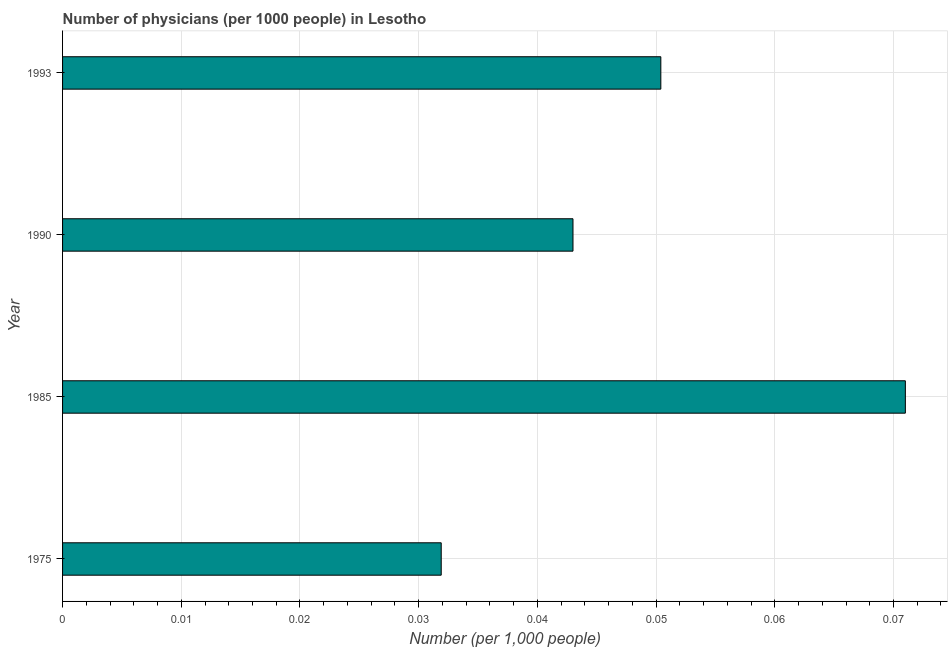Does the graph contain grids?
Your answer should be compact. Yes. What is the title of the graph?
Ensure brevity in your answer.  Number of physicians (per 1000 people) in Lesotho. What is the label or title of the X-axis?
Offer a very short reply. Number (per 1,0 people). What is the label or title of the Y-axis?
Provide a short and direct response. Year. What is the number of physicians in 1985?
Give a very brief answer. 0.07. Across all years, what is the maximum number of physicians?
Your answer should be very brief. 0.07. Across all years, what is the minimum number of physicians?
Offer a terse response. 0.03. In which year was the number of physicians minimum?
Provide a short and direct response. 1975. What is the sum of the number of physicians?
Offer a terse response. 0.2. What is the difference between the number of physicians in 1975 and 1990?
Provide a short and direct response. -0.01. What is the average number of physicians per year?
Your answer should be compact. 0.05. What is the median number of physicians?
Offer a very short reply. 0.05. Do a majority of the years between 1990 and 1985 (inclusive) have number of physicians greater than 0.04 ?
Give a very brief answer. No. What is the ratio of the number of physicians in 1975 to that in 1985?
Your response must be concise. 0.45. Is the number of physicians in 1985 less than that in 1990?
Your answer should be compact. No. Is the difference between the number of physicians in 1975 and 1993 greater than the difference between any two years?
Provide a short and direct response. No. What is the difference between the highest and the second highest number of physicians?
Your answer should be very brief. 0.02. What is the difference between the highest and the lowest number of physicians?
Give a very brief answer. 0.04. What is the difference between two consecutive major ticks on the X-axis?
Make the answer very short. 0.01. What is the Number (per 1,000 people) of 1975?
Your response must be concise. 0.03. What is the Number (per 1,000 people) in 1985?
Provide a short and direct response. 0.07. What is the Number (per 1,000 people) of 1990?
Provide a succinct answer. 0.04. What is the Number (per 1,000 people) of 1993?
Make the answer very short. 0.05. What is the difference between the Number (per 1,000 people) in 1975 and 1985?
Keep it short and to the point. -0.04. What is the difference between the Number (per 1,000 people) in 1975 and 1990?
Offer a terse response. -0.01. What is the difference between the Number (per 1,000 people) in 1975 and 1993?
Provide a short and direct response. -0.02. What is the difference between the Number (per 1,000 people) in 1985 and 1990?
Your answer should be very brief. 0.03. What is the difference between the Number (per 1,000 people) in 1985 and 1993?
Offer a terse response. 0.02. What is the difference between the Number (per 1,000 people) in 1990 and 1993?
Offer a terse response. -0.01. What is the ratio of the Number (per 1,000 people) in 1975 to that in 1985?
Give a very brief answer. 0.45. What is the ratio of the Number (per 1,000 people) in 1975 to that in 1990?
Your response must be concise. 0.74. What is the ratio of the Number (per 1,000 people) in 1975 to that in 1993?
Keep it short and to the point. 0.63. What is the ratio of the Number (per 1,000 people) in 1985 to that in 1990?
Give a very brief answer. 1.65. What is the ratio of the Number (per 1,000 people) in 1985 to that in 1993?
Offer a very short reply. 1.41. What is the ratio of the Number (per 1,000 people) in 1990 to that in 1993?
Make the answer very short. 0.85. 